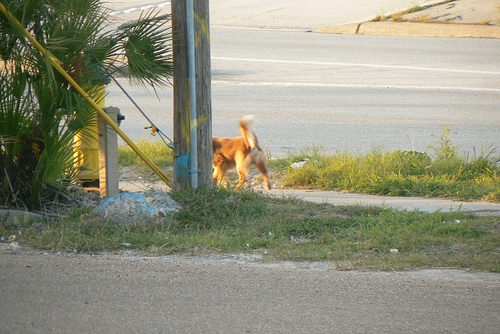<image>
Can you confirm if the dog is behind the pole? Yes. From this viewpoint, the dog is positioned behind the pole, with the pole partially or fully occluding the dog. Where is the dog in relation to the street? Is it on the street? No. The dog is not positioned on the street. They may be near each other, but the dog is not supported by or resting on top of the street. Where is the puppy in relation to the post? Is it in front of the post? No. The puppy is not in front of the post. The spatial positioning shows a different relationship between these objects. 